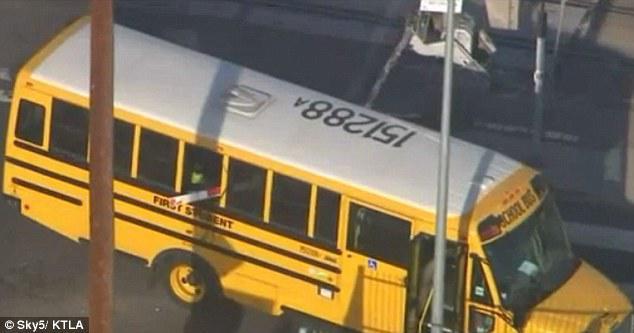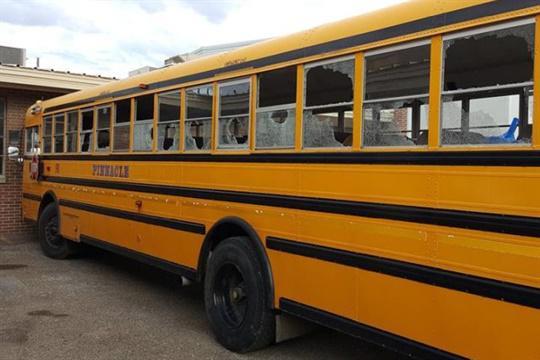The first image is the image on the left, the second image is the image on the right. Analyze the images presented: Is the assertion "A school bus seen from above has a white roof with identifying number, and a handicap access door directly behind a passenger door with steps." valid? Answer yes or no. Yes. The first image is the image on the left, the second image is the image on the right. Evaluate the accuracy of this statement regarding the images: "A number is printed on the top of the bus in one of the images.". Is it true? Answer yes or no. Yes. 